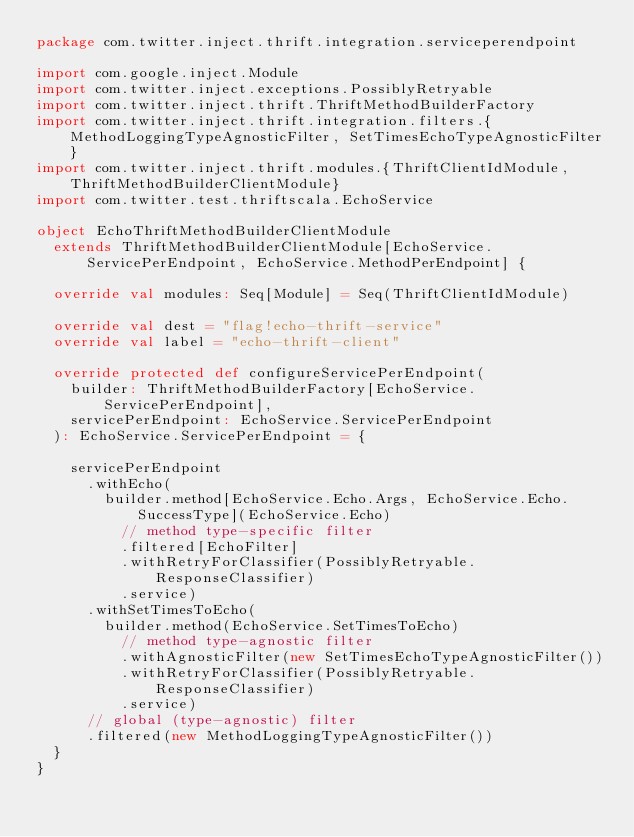<code> <loc_0><loc_0><loc_500><loc_500><_Scala_>package com.twitter.inject.thrift.integration.serviceperendpoint

import com.google.inject.Module
import com.twitter.inject.exceptions.PossiblyRetryable
import com.twitter.inject.thrift.ThriftMethodBuilderFactory
import com.twitter.inject.thrift.integration.filters.{MethodLoggingTypeAgnosticFilter, SetTimesEchoTypeAgnosticFilter}
import com.twitter.inject.thrift.modules.{ThriftClientIdModule, ThriftMethodBuilderClientModule}
import com.twitter.test.thriftscala.EchoService

object EchoThriftMethodBuilderClientModule
  extends ThriftMethodBuilderClientModule[EchoService.ServicePerEndpoint, EchoService.MethodPerEndpoint] {

  override val modules: Seq[Module] = Seq(ThriftClientIdModule)

  override val dest = "flag!echo-thrift-service"
  override val label = "echo-thrift-client"

  override protected def configureServicePerEndpoint(
    builder: ThriftMethodBuilderFactory[EchoService.ServicePerEndpoint],
    servicePerEndpoint: EchoService.ServicePerEndpoint
  ): EchoService.ServicePerEndpoint = {

    servicePerEndpoint
      .withEcho(
        builder.method[EchoService.Echo.Args, EchoService.Echo.SuccessType](EchoService.Echo)
          // method type-specific filter
          .filtered[EchoFilter]
          .withRetryForClassifier(PossiblyRetryable.ResponseClassifier)
          .service)
      .withSetTimesToEcho(
        builder.method(EchoService.SetTimesToEcho)
          // method type-agnostic filter
          .withAgnosticFilter(new SetTimesEchoTypeAgnosticFilter())
          .withRetryForClassifier(PossiblyRetryable.ResponseClassifier)
          .service)
      // global (type-agnostic) filter
      .filtered(new MethodLoggingTypeAgnosticFilter())
  }
}
</code> 